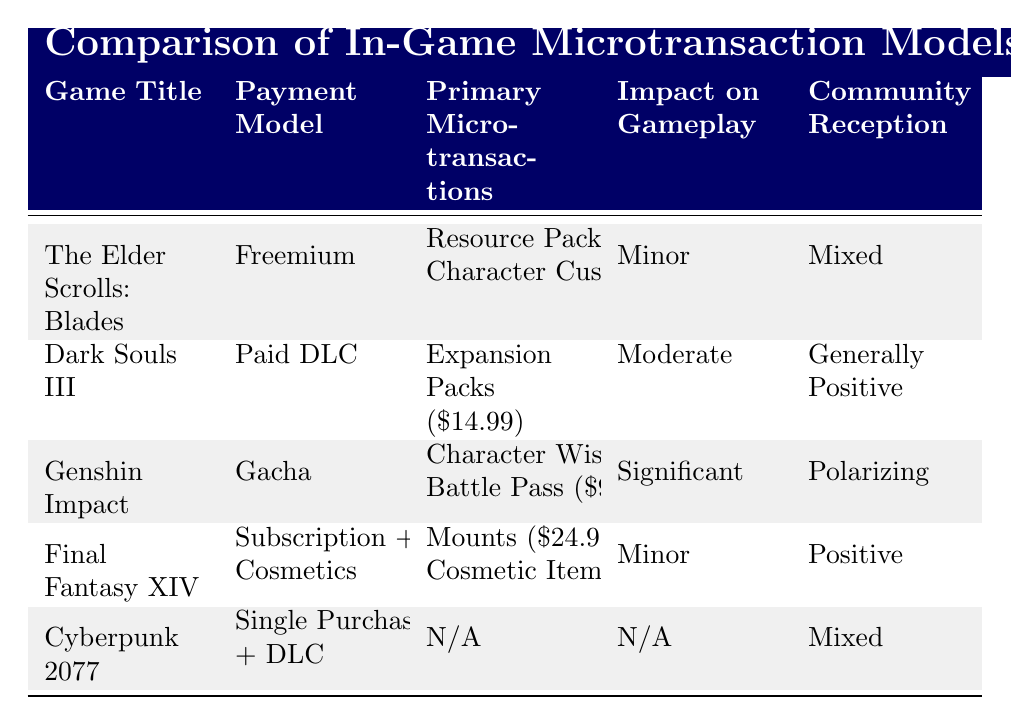What is the payment model for Genshin Impact? The payment model for Genshin Impact is indicated in the table under the "Payment Model" column. It states "Gacha."
Answer: Gacha Which game has the highest price for a single microtransaction item? To determine which game has the highest price for a single microtransaction item, we can compare the individual prices listed. Final Fantasy XIV has a mount at $24.99, while Dark Souls III's expansion packs are $14.99, and the highest price for any item in the other games is less than these values. Therefore, Final Fantasy XIV has the highest price.
Answer: Final Fantasy XIV Is the community reception for Dark Souls III positive? The community reception for Dark Souls III, as per the table, is labeled as "Generally Positive." This indicates that the reception is indeed positive.
Answer: Yes What is the combined price of all primary microtransactions in The Elder Scrolls: Blades? In The Elder Scrolls: Blades, the two primary microtransactions listed are Resource Packs for $4.99 and Character Customization for $0.99. Adding these together gives us a total of $4.99 + $0.99 = $5.98.
Answer: $5.98 For which game is the impact on gameplay reported as "N/A"? Looking at the "Impact on Gameplay" column, we can see that Cyberpunk 2077's impact is marked as "N/A." This indicates no applicable impact is determined, which answers the question directly.
Answer: Cyberpunk 2077 What percentage of games listed have a minor impact on gameplay? There are a total of five games listed in the table. Out of these, two (The Elder Scrolls: Blades and Final Fantasy XIV) have a "Minor" impact. To find the percentage, we calculate (2/5) * 100 = 40%. Thus, 40% of the games have a minor impact on gameplay.
Answer: 40% Is there a game with no primary microtransactions listed? The table specifies that Cyberpunk 2077 has "N/A" under primary microtransactions, which indicates that there are no microtransactions available for this game.
Answer: Yes Which game has a freemium payment model? The table lists The Elder Scrolls: Blades under the "Payment Model" column as "Freemium," which directly answers the question of which game has this model.
Answer: The Elder Scrolls: Blades 